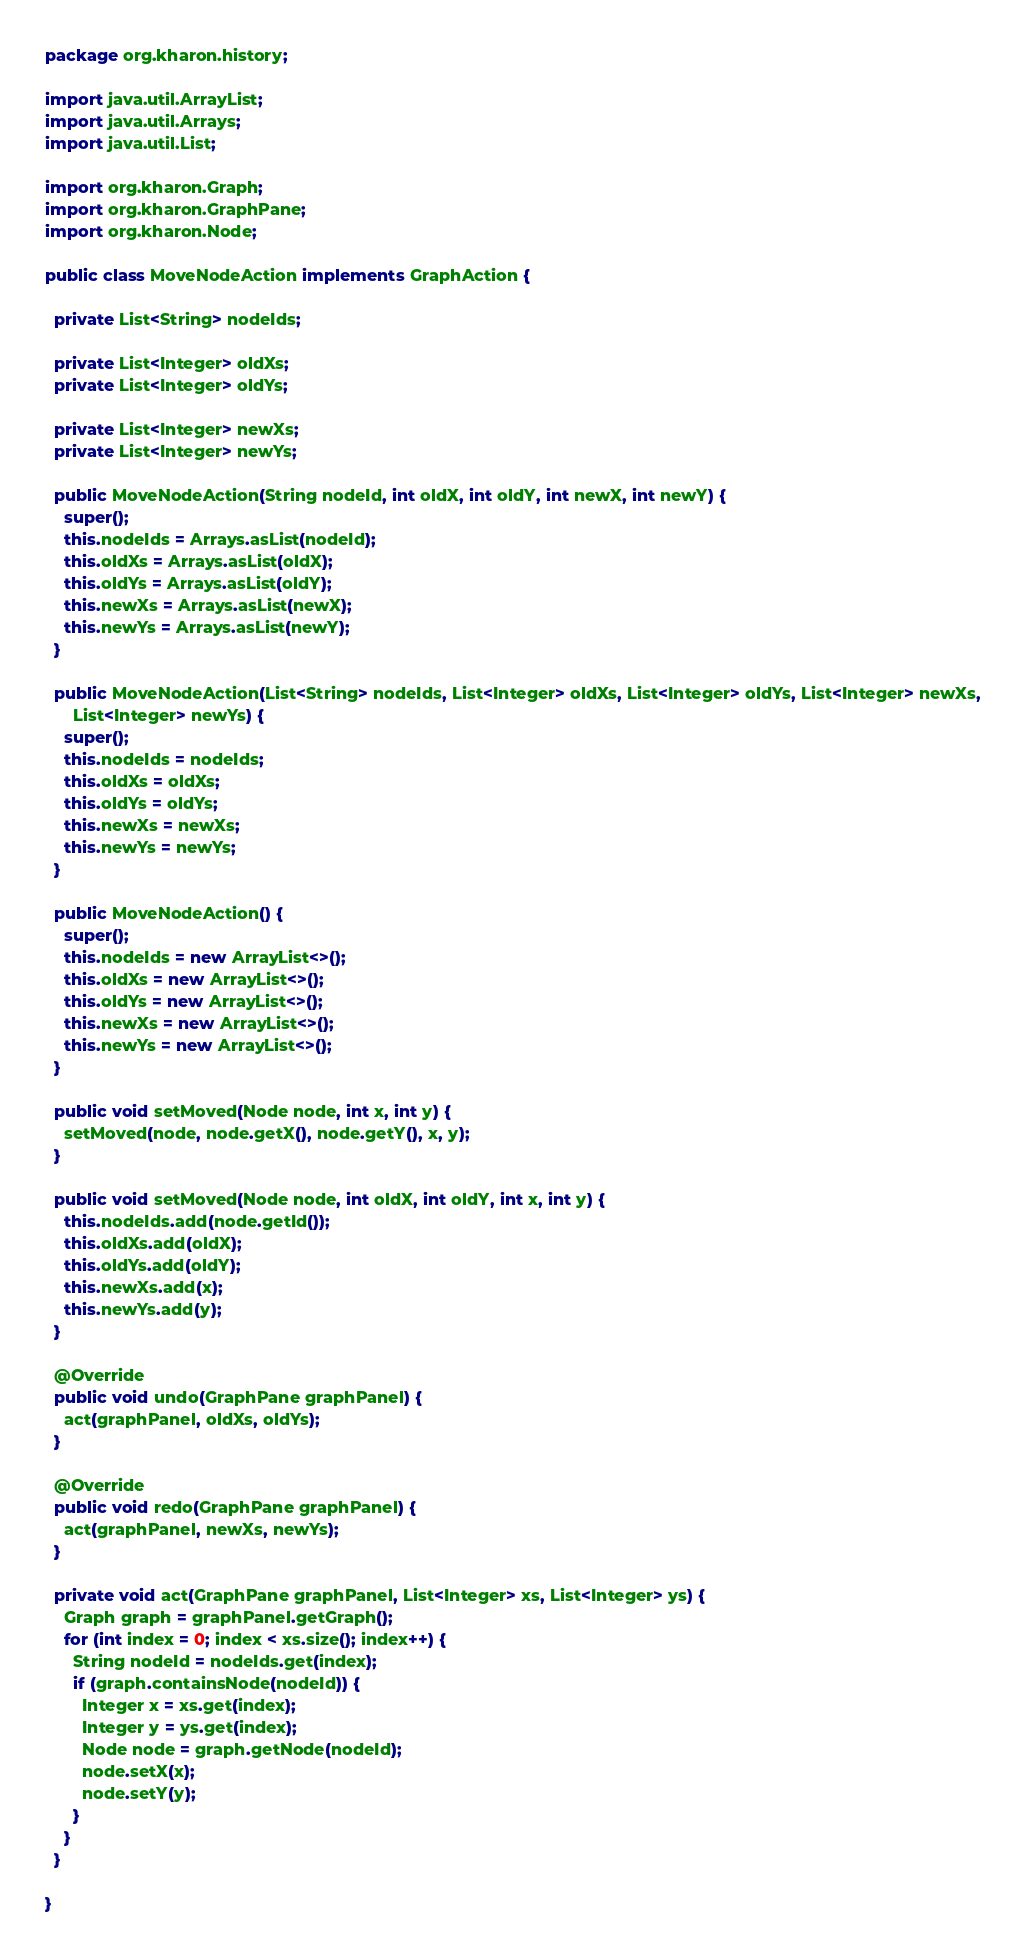Convert code to text. <code><loc_0><loc_0><loc_500><loc_500><_Java_>package org.kharon.history;

import java.util.ArrayList;
import java.util.Arrays;
import java.util.List;

import org.kharon.Graph;
import org.kharon.GraphPane;
import org.kharon.Node;

public class MoveNodeAction implements GraphAction {

  private List<String> nodeIds;

  private List<Integer> oldXs;
  private List<Integer> oldYs;

  private List<Integer> newXs;
  private List<Integer> newYs;

  public MoveNodeAction(String nodeId, int oldX, int oldY, int newX, int newY) {
    super();
    this.nodeIds = Arrays.asList(nodeId);
    this.oldXs = Arrays.asList(oldX);
    this.oldYs = Arrays.asList(oldY);
    this.newXs = Arrays.asList(newX);
    this.newYs = Arrays.asList(newY);
  }

  public MoveNodeAction(List<String> nodeIds, List<Integer> oldXs, List<Integer> oldYs, List<Integer> newXs,
      List<Integer> newYs) {
    super();
    this.nodeIds = nodeIds;
    this.oldXs = oldXs;
    this.oldYs = oldYs;
    this.newXs = newXs;
    this.newYs = newYs;
  }

  public MoveNodeAction() {
    super();
    this.nodeIds = new ArrayList<>();
    this.oldXs = new ArrayList<>();
    this.oldYs = new ArrayList<>();
    this.newXs = new ArrayList<>();
    this.newYs = new ArrayList<>();
  }

  public void setMoved(Node node, int x, int y) {
    setMoved(node, node.getX(), node.getY(), x, y);
  }

  public void setMoved(Node node, int oldX, int oldY, int x, int y) {
    this.nodeIds.add(node.getId());
    this.oldXs.add(oldX);
    this.oldYs.add(oldY);
    this.newXs.add(x);
    this.newYs.add(y);
  }

  @Override
  public void undo(GraphPane graphPanel) {
    act(graphPanel, oldXs, oldYs);
  }

  @Override
  public void redo(GraphPane graphPanel) {
    act(graphPanel, newXs, newYs);
  }

  private void act(GraphPane graphPanel, List<Integer> xs, List<Integer> ys) {
    Graph graph = graphPanel.getGraph();
    for (int index = 0; index < xs.size(); index++) {
      String nodeId = nodeIds.get(index);
      if (graph.containsNode(nodeId)) {
        Integer x = xs.get(index);
        Integer y = ys.get(index);
        Node node = graph.getNode(nodeId);
        node.setX(x);
        node.setY(y);
      }
    }
  }

}
</code> 